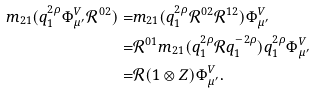<formula> <loc_0><loc_0><loc_500><loc_500>m _ { 2 1 } ( q _ { 1 } ^ { 2 \rho } \Phi ^ { V } _ { \mu ^ { \prime } } \mathcal { R } ^ { 0 2 } ) = & m _ { 2 1 } ( q _ { 1 } ^ { 2 \rho } \mathcal { R } ^ { 0 2 } \mathcal { R } ^ { 1 2 } ) \Phi ^ { V } _ { \mu ^ { \prime } } \\ = & \mathcal { R } ^ { 0 1 } m _ { 2 1 } ( q _ { 1 } ^ { 2 \rho } \mathcal { R } q _ { 1 } ^ { - 2 \rho } ) q _ { 1 } ^ { 2 \rho } \Phi ^ { V } _ { \mu ^ { \prime } } \\ = & \mathcal { R } ( 1 \otimes Z ) \Phi ^ { V } _ { \mu ^ { \prime } } .</formula> 